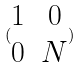Convert formula to latex. <formula><loc_0><loc_0><loc_500><loc_500>( \begin{matrix} 1 & 0 \\ 0 & N \end{matrix} )</formula> 